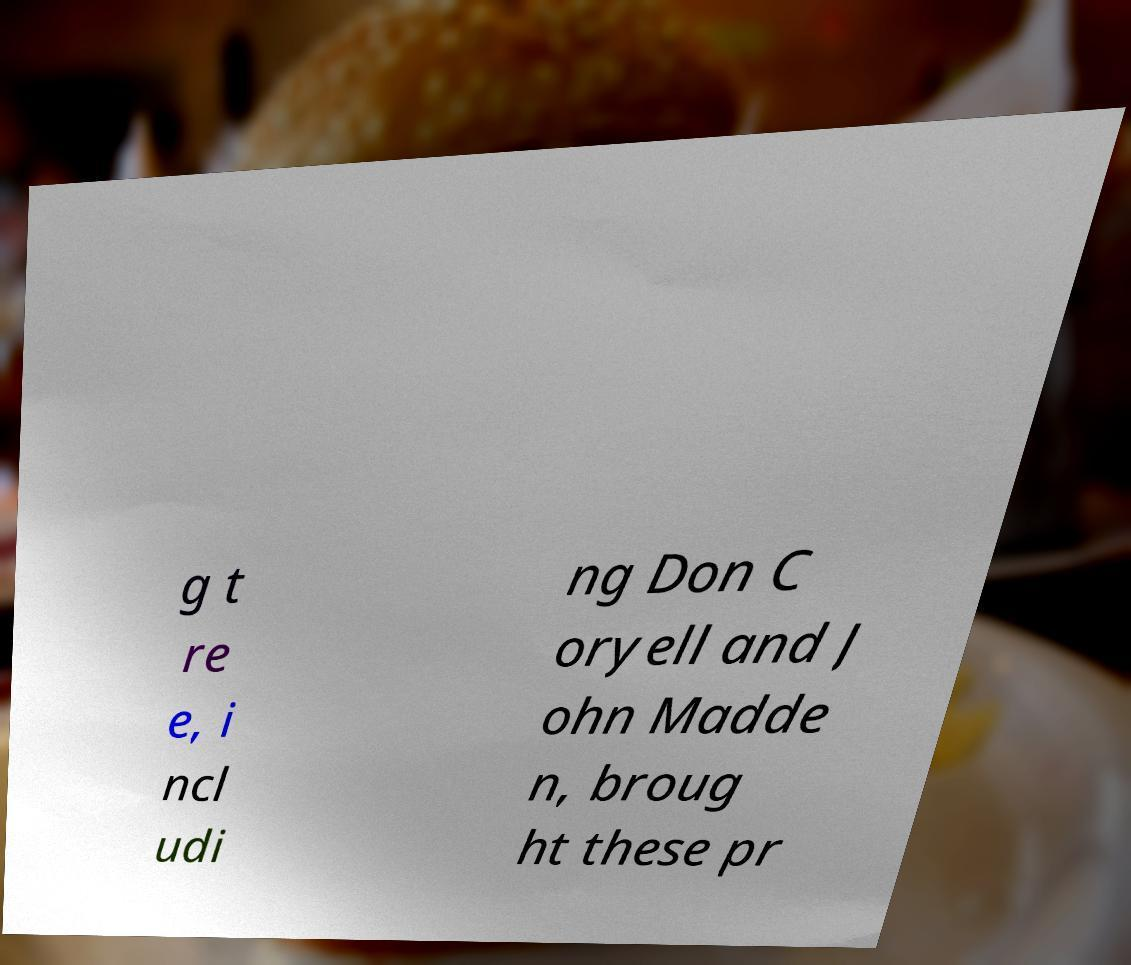What messages or text are displayed in this image? I need them in a readable, typed format. g t re e, i ncl udi ng Don C oryell and J ohn Madde n, broug ht these pr 